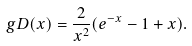Convert formula to latex. <formula><loc_0><loc_0><loc_500><loc_500>\ g D ( x ) = \frac { 2 } { x ^ { 2 } } ( e ^ { - x } - 1 + x ) .</formula> 